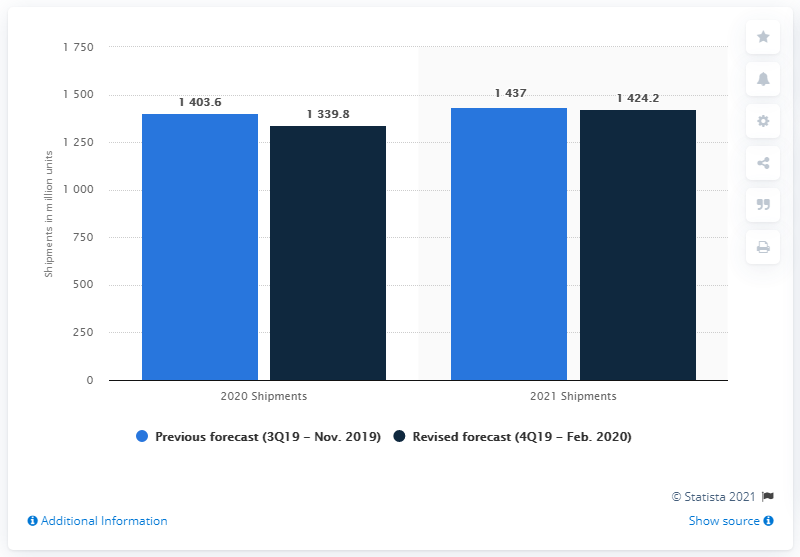Identify some key points in this picture. It is expected that 1403.6 smartphones will be shipped in 2020. The average of 2021 shipments is 1430.6. The shipment forecast has been predicted for the years 2020 and 2021. 